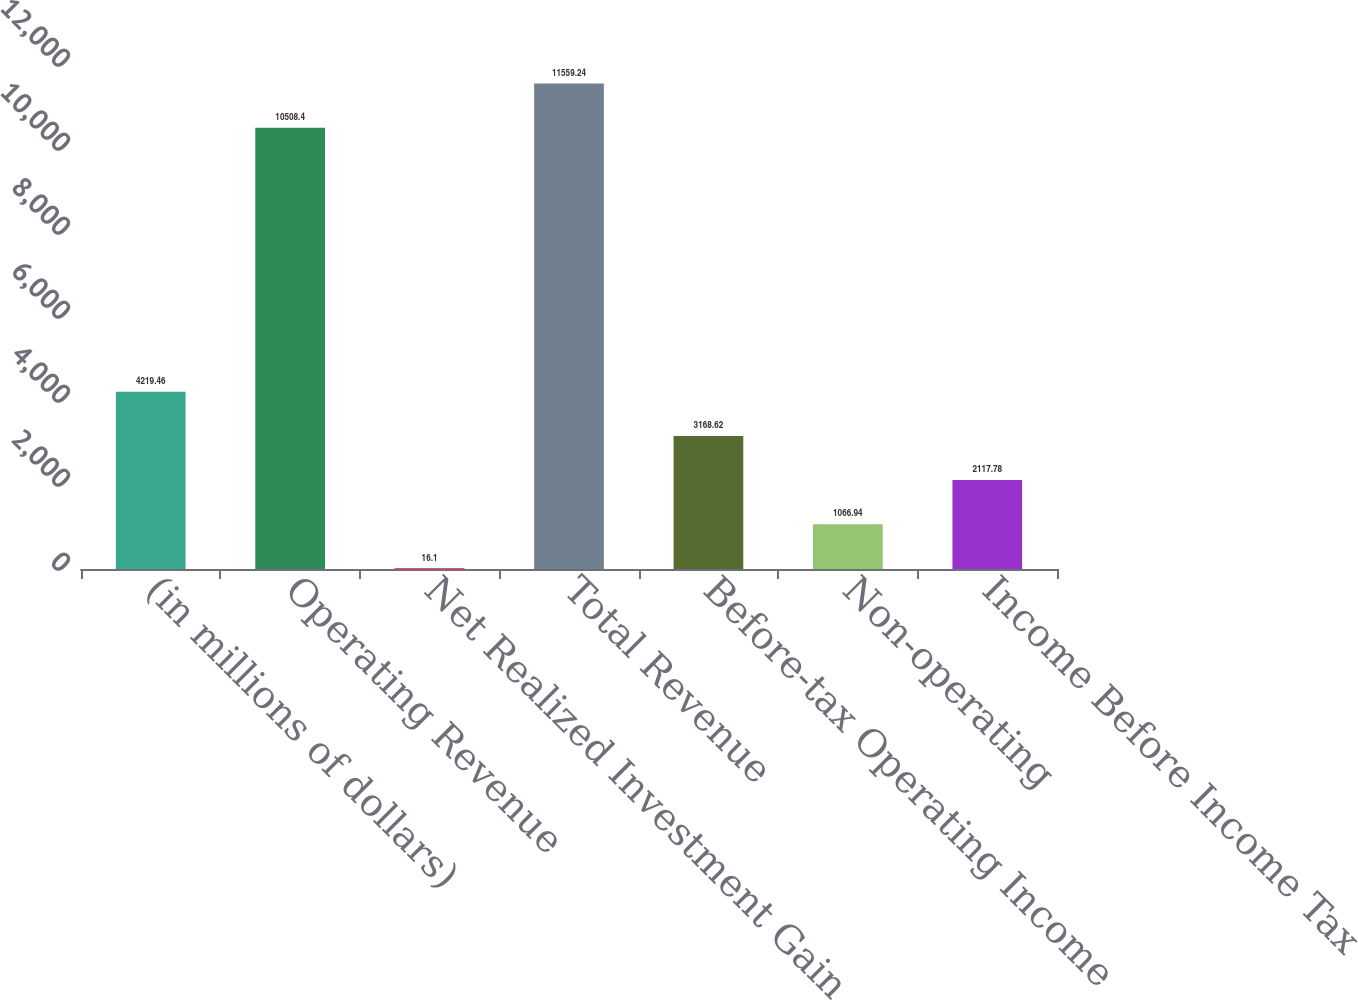<chart> <loc_0><loc_0><loc_500><loc_500><bar_chart><fcel>(in millions of dollars)<fcel>Operating Revenue<fcel>Net Realized Investment Gain<fcel>Total Revenue<fcel>Before-tax Operating Income<fcel>Non-operating<fcel>Income Before Income Tax<nl><fcel>4219.46<fcel>10508.4<fcel>16.1<fcel>11559.2<fcel>3168.62<fcel>1066.94<fcel>2117.78<nl></chart> 